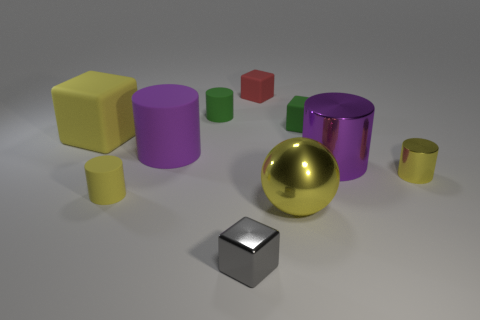The rubber block that is the same color as the shiny sphere is what size?
Ensure brevity in your answer.  Large. What is the shape of the large shiny object that is the same color as the tiny metallic cylinder?
Offer a terse response. Sphere. Are the yellow thing on the right side of the purple shiny cylinder and the tiny green cylinder made of the same material?
Keep it short and to the point. No. Is the number of purple metal cylinders behind the green matte cylinder greater than the number of small cylinders that are to the left of the small green cube?
Offer a very short reply. No. What is the color of the shiny cylinder that is the same size as the gray cube?
Give a very brief answer. Yellow. Are there any large things that have the same color as the metallic cube?
Offer a very short reply. No. Do the large rubber object behind the purple matte cylinder and the block in front of the purple matte object have the same color?
Give a very brief answer. No. What material is the green thing on the right side of the red thing?
Your answer should be very brief. Rubber. What is the color of the big cylinder that is made of the same material as the large yellow cube?
Ensure brevity in your answer.  Purple. How many purple metallic cylinders are the same size as the gray object?
Ensure brevity in your answer.  0. 